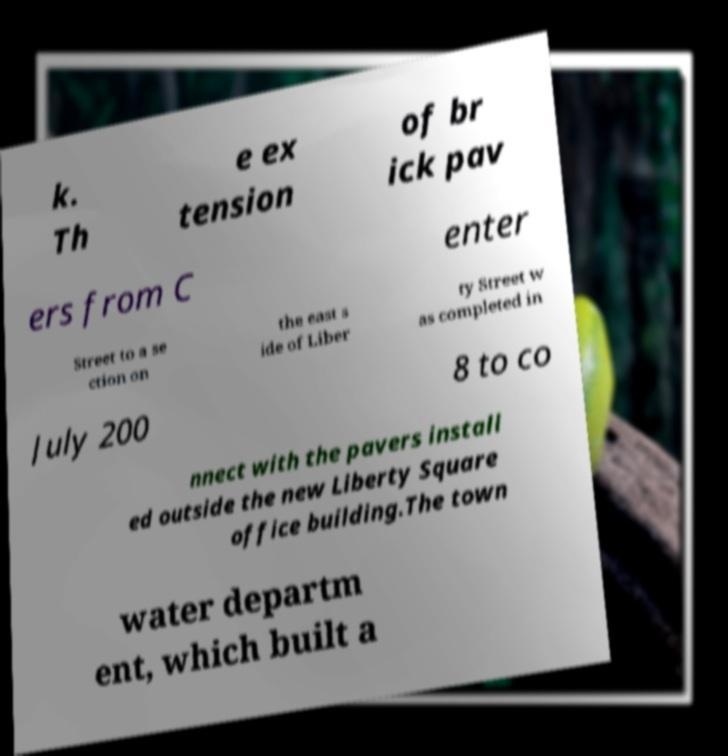Please identify and transcribe the text found in this image. k. Th e ex tension of br ick pav ers from C enter Street to a se ction on the east s ide of Liber ty Street w as completed in July 200 8 to co nnect with the pavers install ed outside the new Liberty Square office building.The town water departm ent, which built a 